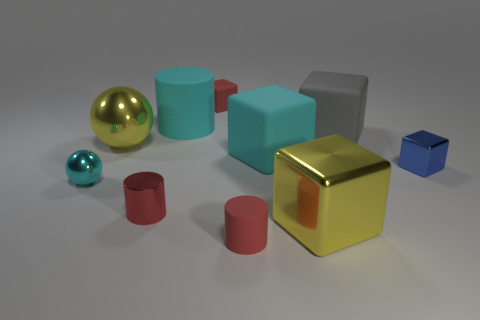Subtract all gray rubber blocks. How many blocks are left? 4 Subtract all cyan cylinders. How many cylinders are left? 2 Add 4 tiny rubber things. How many tiny rubber things exist? 6 Subtract 0 purple cylinders. How many objects are left? 10 Subtract all balls. How many objects are left? 8 Subtract 1 spheres. How many spheres are left? 1 Subtract all cyan cubes. Subtract all yellow cylinders. How many cubes are left? 4 Subtract all yellow blocks. How many blue balls are left? 0 Subtract all small cyan objects. Subtract all cylinders. How many objects are left? 6 Add 3 small red shiny things. How many small red shiny things are left? 4 